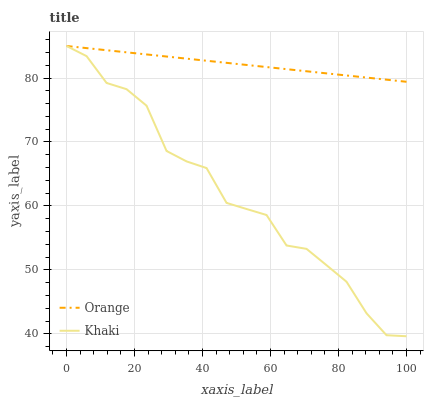Does Khaki have the maximum area under the curve?
Answer yes or no. No. Is Khaki the smoothest?
Answer yes or no. No. 